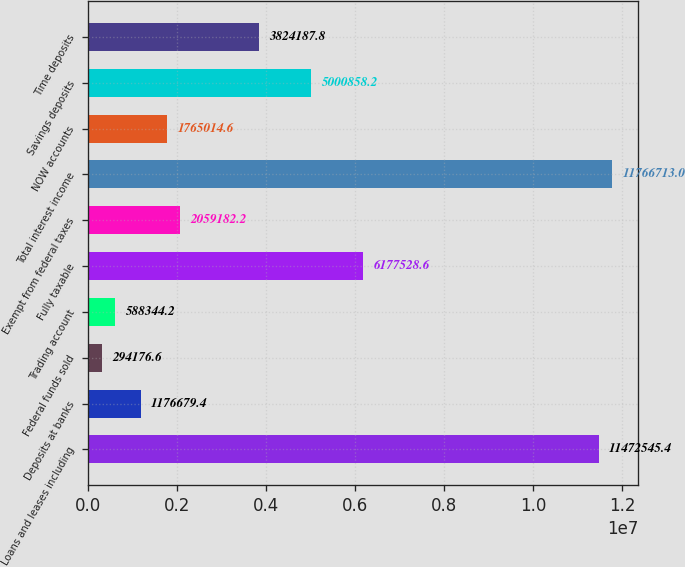Convert chart. <chart><loc_0><loc_0><loc_500><loc_500><bar_chart><fcel>Loans and leases including<fcel>Deposits at banks<fcel>Federal funds sold<fcel>Trading account<fcel>Fully taxable<fcel>Exempt from federal taxes<fcel>Total interest income<fcel>NOW accounts<fcel>Savings deposits<fcel>Time deposits<nl><fcel>1.14725e+07<fcel>1.17668e+06<fcel>294177<fcel>588344<fcel>6.17753e+06<fcel>2.05918e+06<fcel>1.17667e+07<fcel>1.76501e+06<fcel>5.00086e+06<fcel>3.82419e+06<nl></chart> 